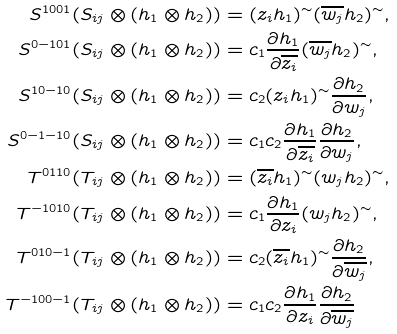<formula> <loc_0><loc_0><loc_500><loc_500>S ^ { 1 0 0 1 } ( S _ { i j } \otimes ( h _ { 1 } \otimes h _ { 2 } ) ) & = ( z _ { i } h _ { 1 } ) ^ { \sim } ( \overline { w _ { j } } h _ { 2 } ) ^ { \sim } , \\ S ^ { 0 - 1 0 1 } ( S _ { i j } \otimes ( h _ { 1 } \otimes h _ { 2 } ) ) & = c _ { 1 } \frac { \partial h _ { 1 } } { \partial \overline { z _ { i } } } ( \overline { w _ { j } } h _ { 2 } ) ^ { \sim } , \\ S ^ { 1 0 - 1 0 } ( S _ { i j } \otimes ( h _ { 1 } \otimes h _ { 2 } ) ) & = c _ { 2 } ( z _ { i } h _ { 1 } ) ^ { \sim } \frac { \partial h _ { 2 } } { \partial w _ { j } } , \\ S ^ { 0 - 1 - 1 0 } ( S _ { i j } \otimes ( h _ { 1 } \otimes h _ { 2 } ) ) & = c _ { 1 } c _ { 2 } \frac { \partial h _ { 1 } } { \partial \overline { z _ { i } } } \frac { \partial h _ { 2 } } { \partial w _ { j } } , \\ T ^ { 0 1 1 0 } ( T _ { i j } \otimes ( h _ { 1 } \otimes h _ { 2 } ) ) & = ( \overline { z _ { i } } h _ { 1 } ) ^ { \sim } ( w _ { j } h _ { 2 } ) ^ { \sim } , \\ T ^ { - 1 0 1 0 } ( T _ { i j } \otimes ( h _ { 1 } \otimes h _ { 2 } ) ) & = c _ { 1 } \frac { \partial h _ { 1 } } { \partial z _ { i } } ( w _ { j } h _ { 2 } ) ^ { \sim } , \\ T ^ { 0 1 0 - 1 } ( T _ { i j } \otimes ( h _ { 1 } \otimes h _ { 2 } ) ) & = c _ { 2 } ( \overline { z _ { i } } h _ { 1 } ) ^ { \sim } \frac { \partial h _ { 2 } } { \partial \overline { w _ { j } } } , \\ T ^ { - 1 0 0 - 1 } ( T _ { i j } \otimes ( h _ { 1 } \otimes h _ { 2 } ) ) & = c _ { 1 } c _ { 2 } \frac { \partial h _ { 1 } } { \partial z _ { i } } \frac { \partial h _ { 2 } } { \partial \overline { w _ { j } } }</formula> 